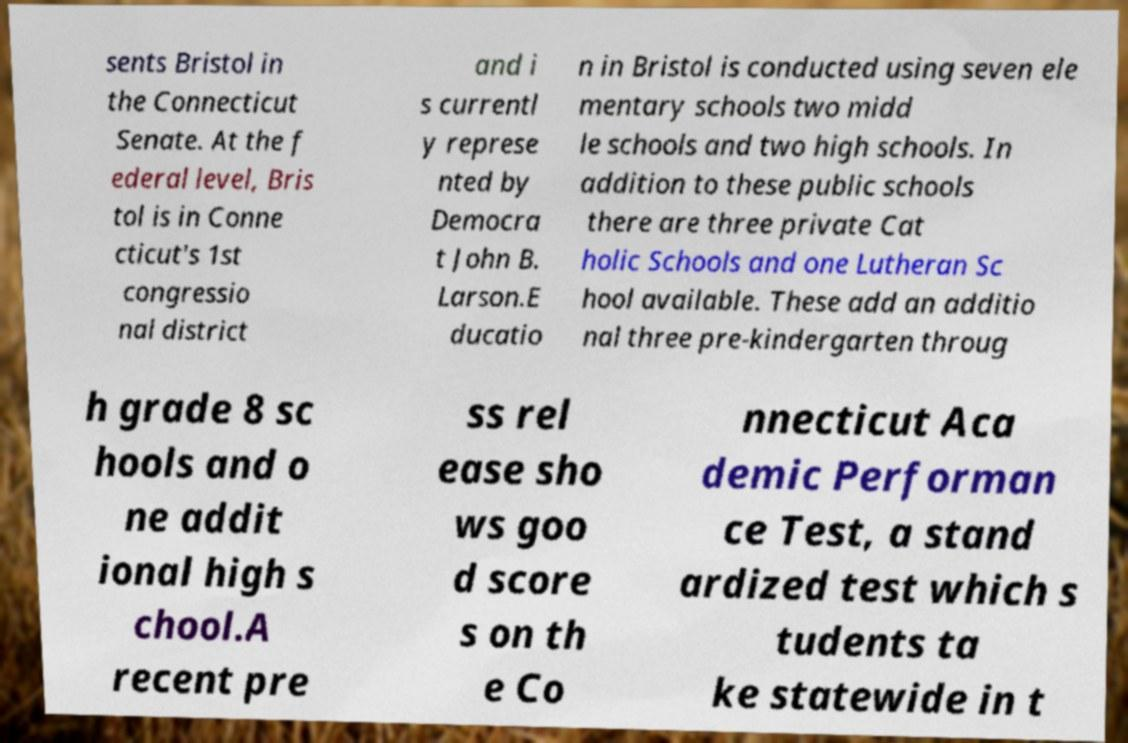Can you accurately transcribe the text from the provided image for me? sents Bristol in the Connecticut Senate. At the f ederal level, Bris tol is in Conne cticut's 1st congressio nal district and i s currentl y represe nted by Democra t John B. Larson.E ducatio n in Bristol is conducted using seven ele mentary schools two midd le schools and two high schools. In addition to these public schools there are three private Cat holic Schools and one Lutheran Sc hool available. These add an additio nal three pre-kindergarten throug h grade 8 sc hools and o ne addit ional high s chool.A recent pre ss rel ease sho ws goo d score s on th e Co nnecticut Aca demic Performan ce Test, a stand ardized test which s tudents ta ke statewide in t 